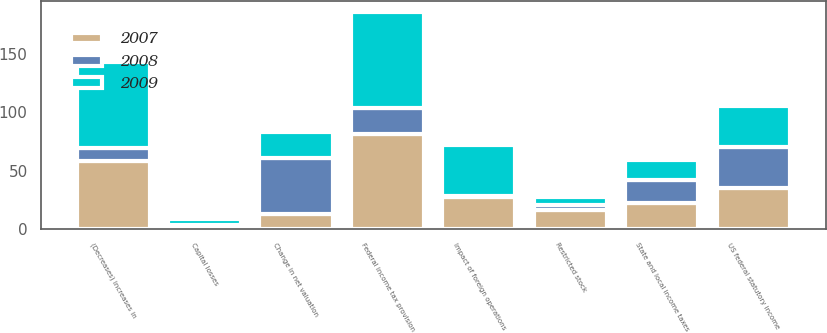Convert chart. <chart><loc_0><loc_0><loc_500><loc_500><stacked_bar_chart><ecel><fcel>US federal statutory income<fcel>Federal income tax provision<fcel>State and local income taxes<fcel>Impact of foreign operations<fcel>Change in net valuation<fcel>(Decreases) increases in<fcel>Restricted stock<fcel>Capital losses<nl><fcel>2007<fcel>35<fcel>81.3<fcel>22.1<fcel>26.9<fcel>12.4<fcel>57.9<fcel>16.4<fcel>1.4<nl><fcel>2008<fcel>35<fcel>22.1<fcel>20.1<fcel>0.9<fcel>48<fcel>11.8<fcel>4<fcel>1.5<nl><fcel>2009<fcel>35<fcel>82.5<fcel>17.2<fcel>44.3<fcel>22.3<fcel>73.6<fcel>6.7<fcel>5.5<nl></chart> 